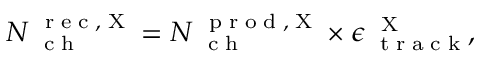Convert formula to latex. <formula><loc_0><loc_0><loc_500><loc_500>N _ { c h } ^ { r e c , X } = N _ { c h } ^ { p r o d , X } \times \epsilon _ { t r a c k } ^ { X } ,</formula> 